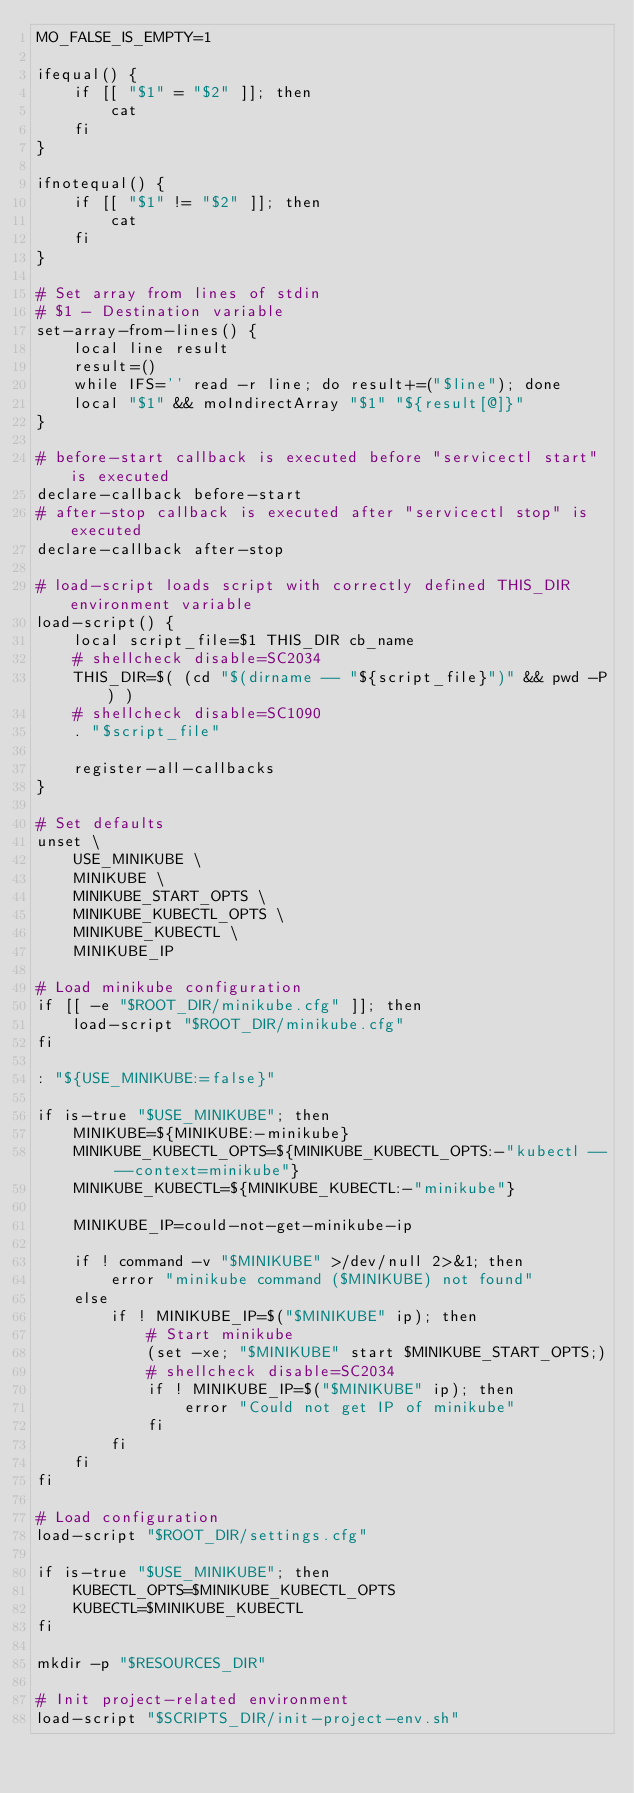Convert code to text. <code><loc_0><loc_0><loc_500><loc_500><_Bash_>MO_FALSE_IS_EMPTY=1

ifequal() {
    if [[ "$1" = "$2" ]]; then
        cat
    fi
}

ifnotequal() {
    if [[ "$1" != "$2" ]]; then
        cat
    fi
}

# Set array from lines of stdin
# $1 - Destination variable
set-array-from-lines() {
    local line result
    result=()
    while IFS='' read -r line; do result+=("$line"); done
    local "$1" && moIndirectArray "$1" "${result[@]}"
}

# before-start callback is executed before "servicectl start" is executed
declare-callback before-start
# after-stop callback is executed after "servicectl stop" is executed
declare-callback after-stop

# load-script loads script with correctly defined THIS_DIR environment variable
load-script() {
    local script_file=$1 THIS_DIR cb_name
    # shellcheck disable=SC2034
    THIS_DIR=$( (cd "$(dirname -- "${script_file}")" && pwd -P) )
    # shellcheck disable=SC1090
    . "$script_file"

    register-all-callbacks
}

# Set defaults
unset \
    USE_MINIKUBE \
    MINIKUBE \
    MINIKUBE_START_OPTS \
    MINIKUBE_KUBECTL_OPTS \
    MINIKUBE_KUBECTL \
    MINIKUBE_IP

# Load minikube configuration
if [[ -e "$ROOT_DIR/minikube.cfg" ]]; then
    load-script "$ROOT_DIR/minikube.cfg"
fi

: "${USE_MINIKUBE:=false}"

if is-true "$USE_MINIKUBE"; then
    MINIKUBE=${MINIKUBE:-minikube}
    MINIKUBE_KUBECTL_OPTS=${MINIKUBE_KUBECTL_OPTS:-"kubectl -- --context=minikube"}
    MINIKUBE_KUBECTL=${MINIKUBE_KUBECTL:-"minikube"}

    MINIKUBE_IP=could-not-get-minikube-ip

    if ! command -v "$MINIKUBE" >/dev/null 2>&1; then
        error "minikube command ($MINIKUBE) not found"
    else
        if ! MINIKUBE_IP=$("$MINIKUBE" ip); then
            # Start minikube
            (set -xe; "$MINIKUBE" start $MINIKUBE_START_OPTS;)
            # shellcheck disable=SC2034
            if ! MINIKUBE_IP=$("$MINIKUBE" ip); then
                error "Could not get IP of minikube"
            fi
        fi
    fi
fi

# Load configuration
load-script "$ROOT_DIR/settings.cfg"

if is-true "$USE_MINIKUBE"; then
    KUBECTL_OPTS=$MINIKUBE_KUBECTL_OPTS
    KUBECTL=$MINIKUBE_KUBECTL
fi

mkdir -p "$RESOURCES_DIR"

# Init project-related environment
load-script "$SCRIPTS_DIR/init-project-env.sh"
</code> 